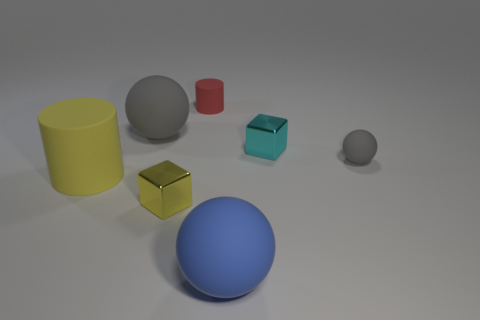Add 3 big red metallic blocks. How many objects exist? 10 Subtract all cubes. How many objects are left? 5 Subtract all tiny red things. Subtract all large red rubber cubes. How many objects are left? 6 Add 2 large gray rubber spheres. How many large gray rubber spheres are left? 3 Add 5 large things. How many large things exist? 8 Subtract 0 cyan cylinders. How many objects are left? 7 